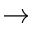Convert formula to latex. <formula><loc_0><loc_0><loc_500><loc_500>\rightarrow</formula> 